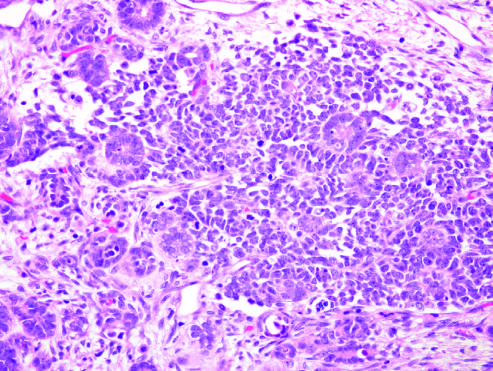what is consistented with the blastemal component and interspersed primitive tubules, representing the epithelial component?
Answer the question using a single word or phrase. Wilms tumor with tightly packed blue cells 